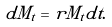<formula> <loc_0><loc_0><loc_500><loc_500>d M _ { t } = r M _ { t } d t .</formula> 